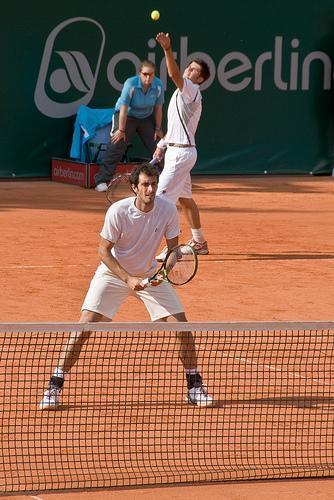How many players are on the court?
Give a very brief answer. 2. 